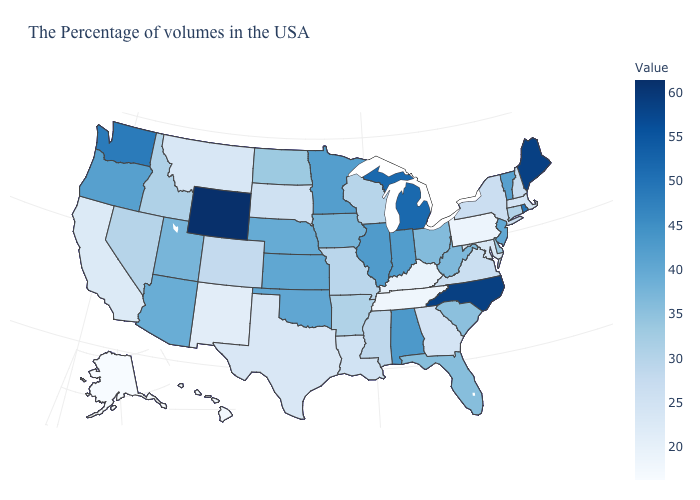Which states hav the highest value in the West?
Keep it brief. Wyoming. Which states have the lowest value in the South?
Give a very brief answer. Tennessee. Does South Dakota have the lowest value in the MidWest?
Concise answer only. Yes. Is the legend a continuous bar?
Be succinct. Yes. Does Washington have the lowest value in the USA?
Concise answer only. No. Which states have the highest value in the USA?
Answer briefly. Wyoming. Does South Carolina have a higher value than Indiana?
Write a very short answer. No. Does Michigan have the lowest value in the MidWest?
Answer briefly. No. 